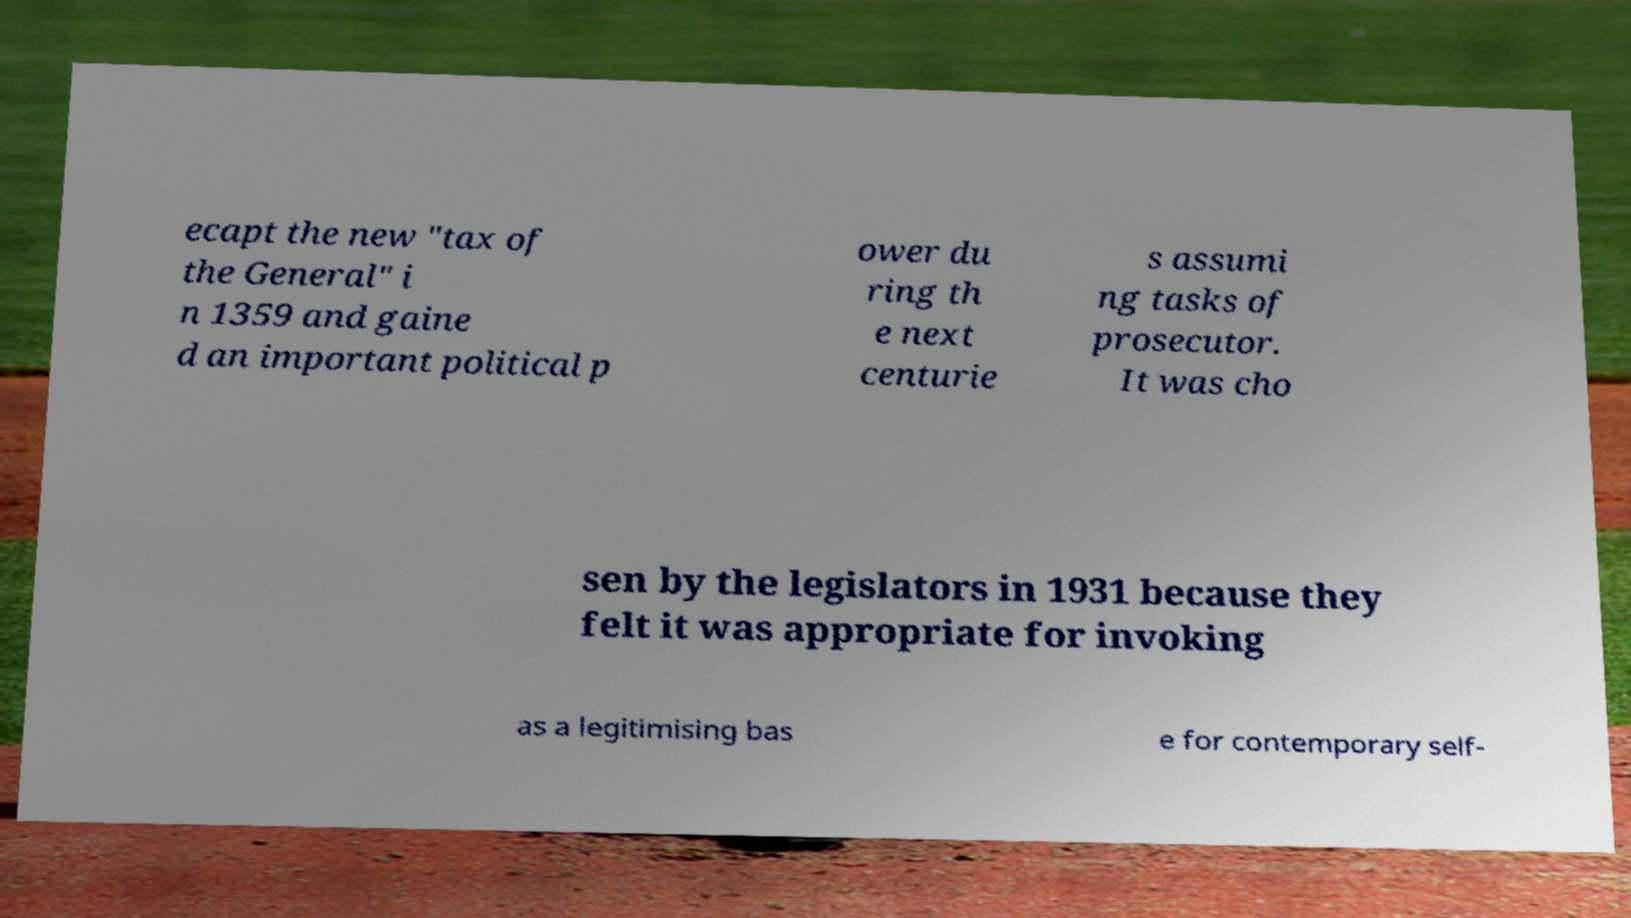There's text embedded in this image that I need extracted. Can you transcribe it verbatim? ecapt the new "tax of the General" i n 1359 and gaine d an important political p ower du ring th e next centurie s assumi ng tasks of prosecutor. It was cho sen by the legislators in 1931 because they felt it was appropriate for invoking as a legitimising bas e for contemporary self- 